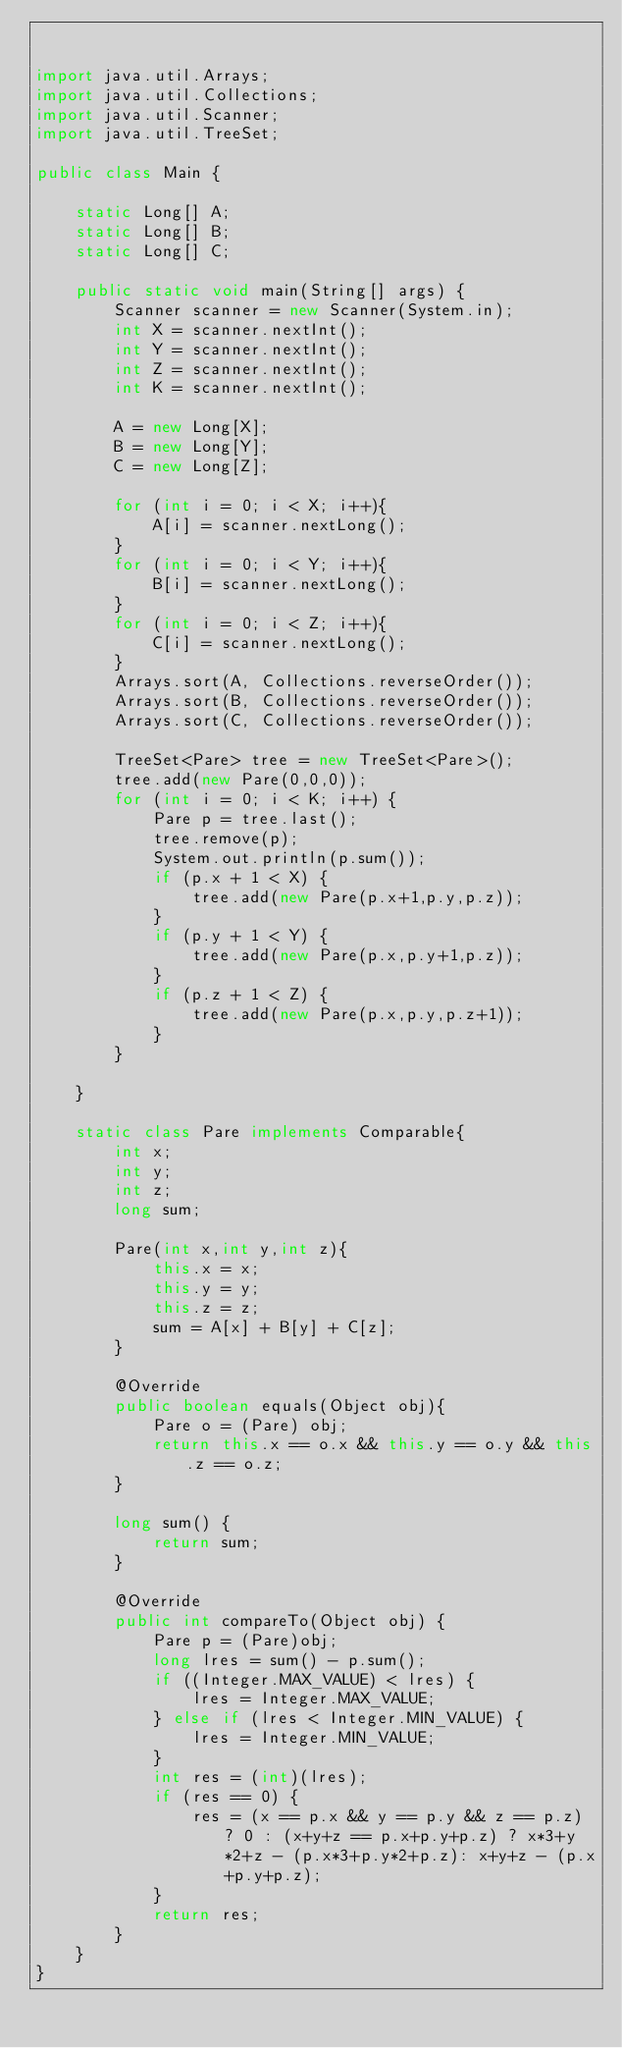Convert code to text. <code><loc_0><loc_0><loc_500><loc_500><_Java_>

import java.util.Arrays;
import java.util.Collections;
import java.util.Scanner;
import java.util.TreeSet;

public class Main {

    static Long[] A;
    static Long[] B;
    static Long[] C;

    public static void main(String[] args) {
        Scanner scanner = new Scanner(System.in);
        int X = scanner.nextInt();
        int Y = scanner.nextInt();
        int Z = scanner.nextInt();
        int K = scanner.nextInt();

        A = new Long[X];
        B = new Long[Y];
        C = new Long[Z];

        for (int i = 0; i < X; i++){
            A[i] = scanner.nextLong();
        }
        for (int i = 0; i < Y; i++){
            B[i] = scanner.nextLong();
        }
        for (int i = 0; i < Z; i++){
            C[i] = scanner.nextLong();
        }
        Arrays.sort(A, Collections.reverseOrder());
        Arrays.sort(B, Collections.reverseOrder());
        Arrays.sort(C, Collections.reverseOrder());

        TreeSet<Pare> tree = new TreeSet<Pare>();
        tree.add(new Pare(0,0,0));
        for (int i = 0; i < K; i++) {
            Pare p = tree.last();
            tree.remove(p);
            System.out.println(p.sum());
            if (p.x + 1 < X) {
                tree.add(new Pare(p.x+1,p.y,p.z));
            }
            if (p.y + 1 < Y) {
                tree.add(new Pare(p.x,p.y+1,p.z));
            }
            if (p.z + 1 < Z) {
                tree.add(new Pare(p.x,p.y,p.z+1));
            }
        }

    }

    static class Pare implements Comparable{
        int x;
        int y;
        int z;
        long sum;

        Pare(int x,int y,int z){
            this.x = x;
            this.y = y;
            this.z = z;
            sum = A[x] + B[y] + C[z];
        }

        @Override
        public boolean equals(Object obj){
            Pare o = (Pare) obj;
            return this.x == o.x && this.y == o.y && this.z == o.z;
        }

        long sum() {
            return sum;
        }

        @Override
        public int compareTo(Object obj) {
            Pare p = (Pare)obj;
            long lres = sum() - p.sum();
            if ((Integer.MAX_VALUE) < lres) {
                lres = Integer.MAX_VALUE;
            } else if (lres < Integer.MIN_VALUE) {
                lres = Integer.MIN_VALUE;
            }
            int res = (int)(lres);
            if (res == 0) {
                res = (x == p.x && y == p.y && z == p.z) ? 0 : (x+y+z == p.x+p.y+p.z) ? x*3+y*2+z - (p.x*3+p.y*2+p.z): x+y+z - (p.x+p.y+p.z);
            }
            return res;
        }
    }
}


</code> 